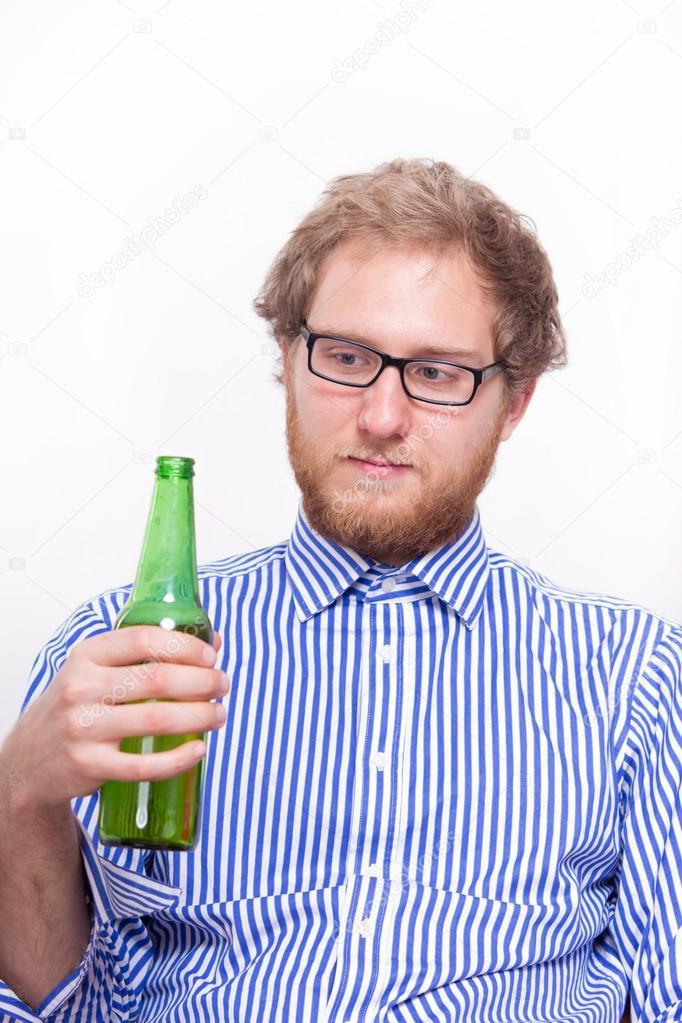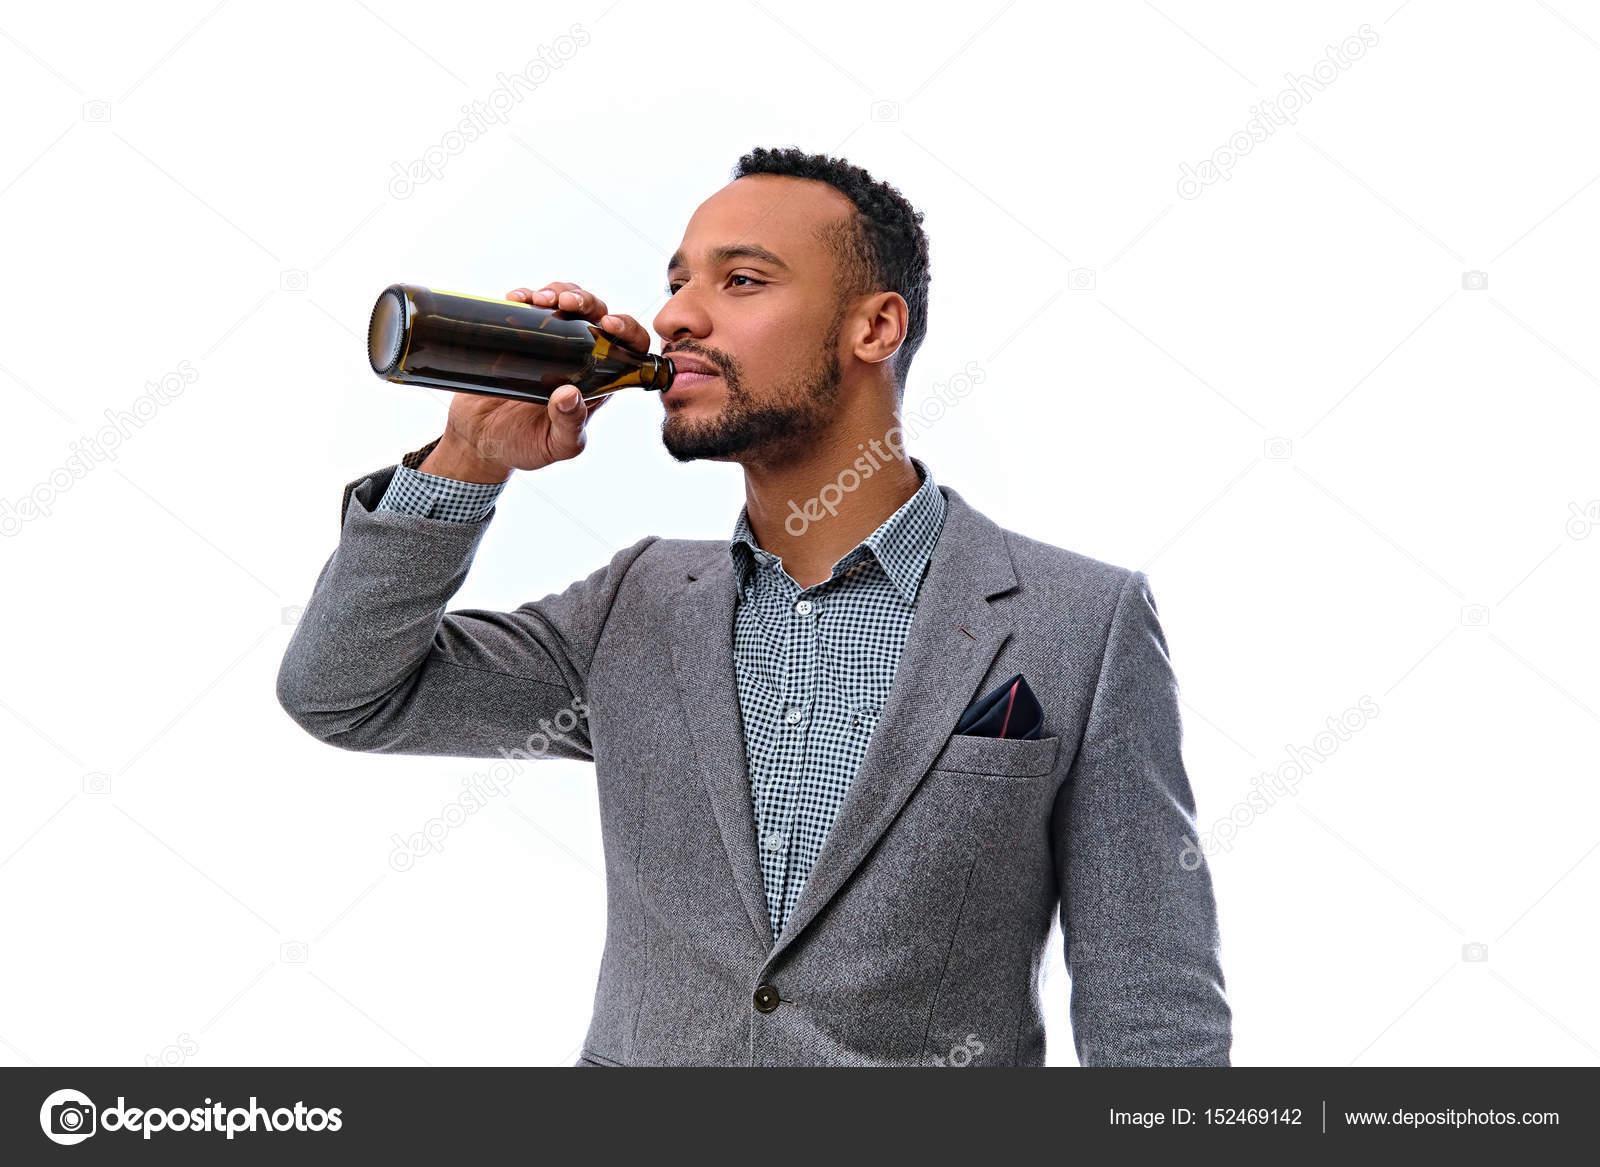The first image is the image on the left, the second image is the image on the right. For the images shown, is this caption "There are two men and two bottles." true? Answer yes or no. Yes. The first image is the image on the left, the second image is the image on the right. Analyze the images presented: Is the assertion "A person is holding a bottle above his open mouth." valid? Answer yes or no. No. 